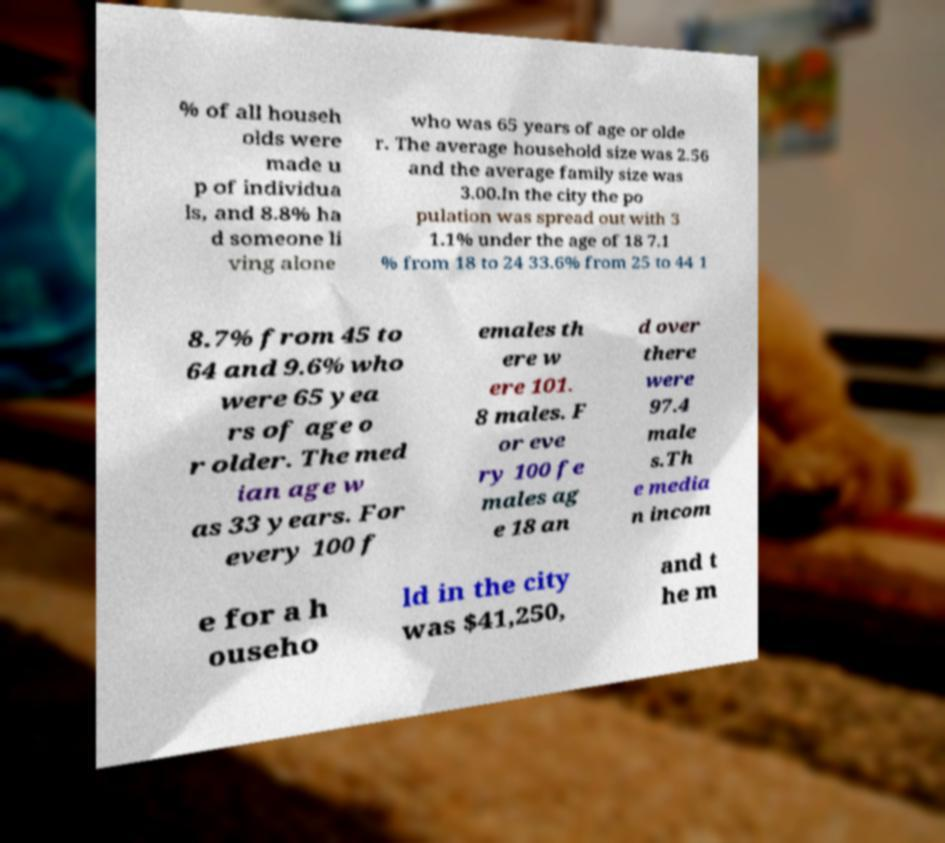I need the written content from this picture converted into text. Can you do that? % of all househ olds were made u p of individua ls, and 8.8% ha d someone li ving alone who was 65 years of age or olde r. The average household size was 2.56 and the average family size was 3.00.In the city the po pulation was spread out with 3 1.1% under the age of 18 7.1 % from 18 to 24 33.6% from 25 to 44 1 8.7% from 45 to 64 and 9.6% who were 65 yea rs of age o r older. The med ian age w as 33 years. For every 100 f emales th ere w ere 101. 8 males. F or eve ry 100 fe males ag e 18 an d over there were 97.4 male s.Th e media n incom e for a h ouseho ld in the city was $41,250, and t he m 